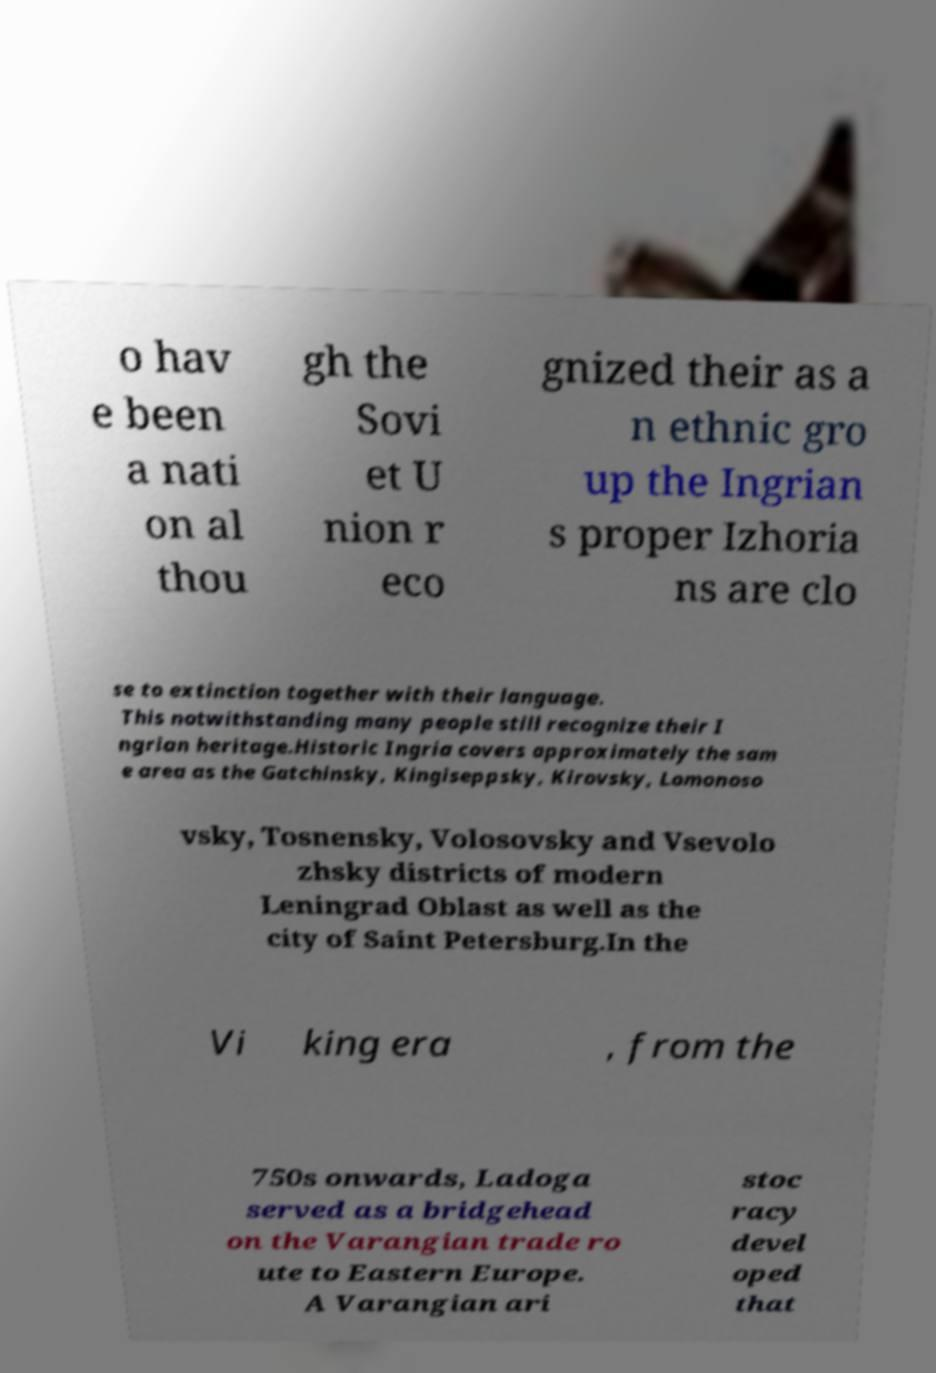What messages or text are displayed in this image? I need them in a readable, typed format. o hav e been a nati on al thou gh the Sovi et U nion r eco gnized their as a n ethnic gro up the Ingrian s proper Izhoria ns are clo se to extinction together with their language. This notwithstanding many people still recognize their I ngrian heritage.Historic Ingria covers approximately the sam e area as the Gatchinsky, Kingiseppsky, Kirovsky, Lomonoso vsky, Tosnensky, Volosovsky and Vsevolo zhsky districts of modern Leningrad Oblast as well as the city of Saint Petersburg.In the Vi king era , from the 750s onwards, Ladoga served as a bridgehead on the Varangian trade ro ute to Eastern Europe. A Varangian ari stoc racy devel oped that 